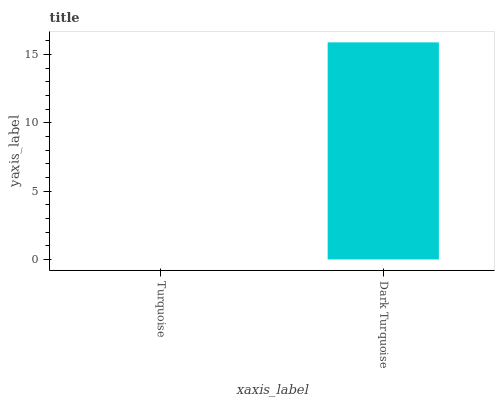Is Turquoise the minimum?
Answer yes or no. Yes. Is Dark Turquoise the maximum?
Answer yes or no. Yes. Is Dark Turquoise the minimum?
Answer yes or no. No. Is Dark Turquoise greater than Turquoise?
Answer yes or no. Yes. Is Turquoise less than Dark Turquoise?
Answer yes or no. Yes. Is Turquoise greater than Dark Turquoise?
Answer yes or no. No. Is Dark Turquoise less than Turquoise?
Answer yes or no. No. Is Dark Turquoise the high median?
Answer yes or no. Yes. Is Turquoise the low median?
Answer yes or no. Yes. Is Turquoise the high median?
Answer yes or no. No. Is Dark Turquoise the low median?
Answer yes or no. No. 